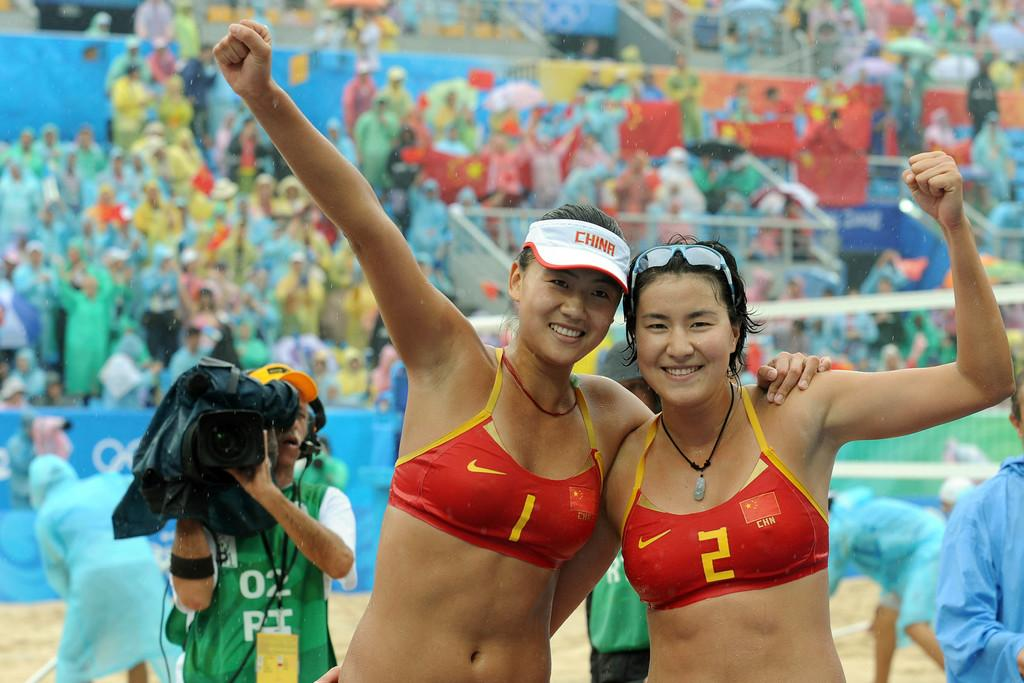<image>
Create a compact narrative representing the image presented. The victorious team celebrates another professional volleyball victory. 